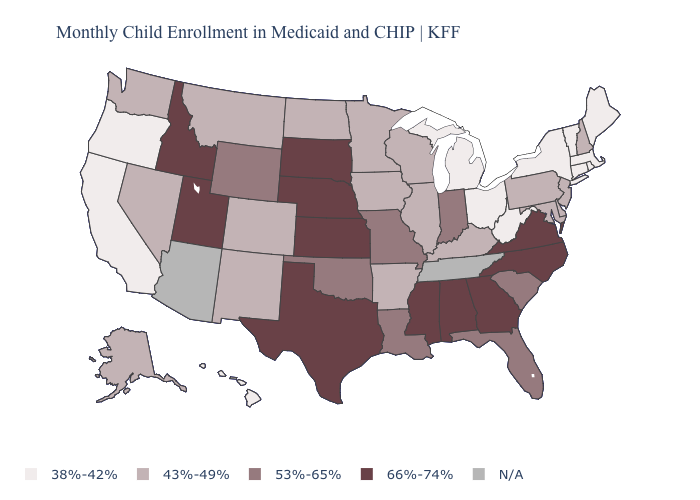Name the states that have a value in the range N/A?
Quick response, please. Arizona, Tennessee. Which states have the lowest value in the USA?
Concise answer only. California, Connecticut, Hawaii, Maine, Massachusetts, Michigan, New York, Ohio, Oregon, Rhode Island, Vermont, West Virginia. Does West Virginia have the lowest value in the USA?
Quick response, please. Yes. What is the value of Michigan?
Concise answer only. 38%-42%. Name the states that have a value in the range 53%-65%?
Quick response, please. Florida, Indiana, Louisiana, Missouri, Oklahoma, South Carolina, Wyoming. Name the states that have a value in the range N/A?
Answer briefly. Arizona, Tennessee. What is the value of Oregon?
Be succinct. 38%-42%. What is the value of Hawaii?
Answer briefly. 38%-42%. What is the lowest value in the USA?
Quick response, please. 38%-42%. Name the states that have a value in the range N/A?
Short answer required. Arizona, Tennessee. What is the highest value in states that border Oklahoma?
Be succinct. 66%-74%. 